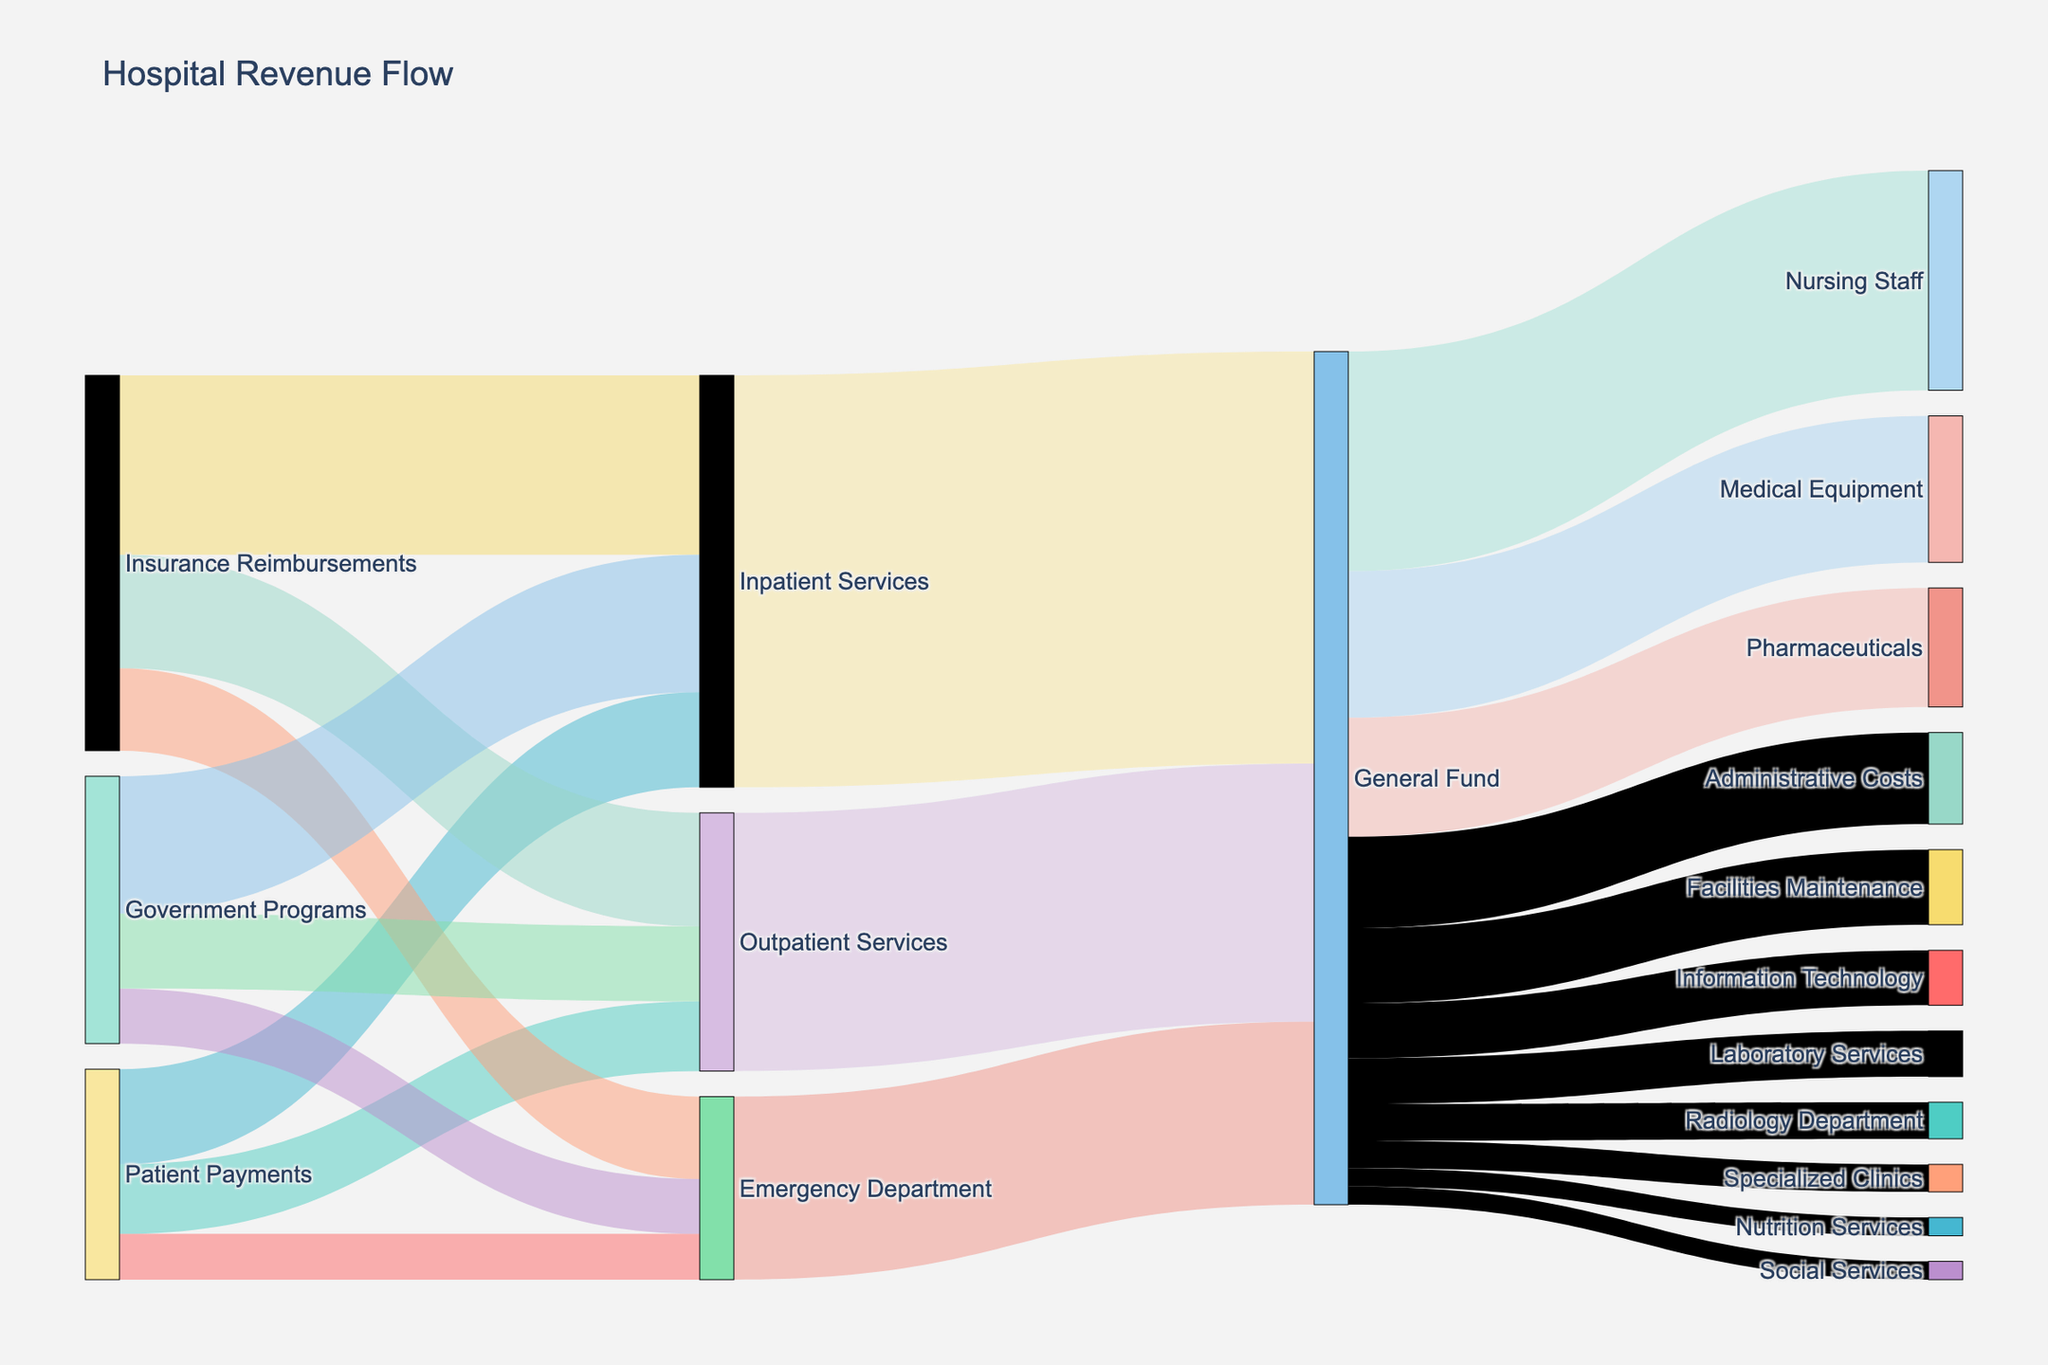What is the title of the diagram? The title of the diagram is prominently displayed at the top of the figure.
Answer: "Hospital Revenue Flow" What are the largest and smallest revenue contributions from Patient Payments? By looking at the width of the flows coming from "Patient Payments," we can see that their largest contribution is to "Inpatient Services" and the smallest is to the "Emergency Department".
Answer: Largest: "Inpatient Services", Smallest: "Emergency Department" Which department receives the highest total revenue from all sources combined? Summing the flows into each department (Emergency Department, Outpatient Services, Inpatient Services) from all sources (Patient Payments, Insurance Reimbursements, Government Programs), we see that "Inpatient Services" receives the most. Specifically, 5200000 from Patient Payments, 9800000 from Insurance Reimbursements, and 7500000 from Government Programs equal 22500000.
Answer: "Inpatient Services" How much revenue does the General Fund allocate to Medical Equipment and Nursing Staff? The flows from "General Fund" to "Medical Equipment" and "Nursing Staff" are visible, summing to 8000000 and 12000000 respectively.
Answer: $20,000,000 combined What is the combined value of revenues from Government Programs to the Emergency Department and Outpatient Services? Adding the values of the flows from "Government Programs" to "Emergency Department" and "Outpatient Services" gives 3000000 + 4100000.
Answer: $7,100,000 Compare the revenues from Insurance Reimbursements to Inpatient Services and Outpatient Services. Which is higher and by how much? By comparing the figures directly, Insurance Reimbursements to "Inpatient Services" is 9800000, and to "Outpatient Services" is 6200000. The difference is 9800000 - 6200000.
Answer: "Inpatient Services" by $3,600,000 What is the total revenue that flows into the General Fund from all departments? Adding the flows into "General Fund" from "Emergency Department" (10000000), "Outpatient Services" (14100000), and "Inpatient Services" (22500000) gives 10000000 + 14100000 + 22500000.
Answer: $46,000,000 Identify two services with equal funds allocated from the General Fund. Observing the flows from the "General Fund," "Social Services" and "Nutrition Services" each receive an equal allocation of 1000000.
Answer: "Social Services" and "Nutrition Services" Which flow is larger: from Government Programs to Emergency Department or from Patient Payments to Outpatient Services? By comparing the two specific flows, Government Programs to "Emergency Department" is 3000000, and Patient Payments to "Outpatient Services" is 3800000.
Answer: "Patient Payments to Outpatient Services" Determine the total revenue from Patient Payments and Insurance Reimbursements combined for Outpatient Services. Adding revenue from "Patient Payments" and "Insurance Reimbursements" to "Outpatient Services," 3800000 from Patient Payments and 6200000 from Insurance Reimbursements gives 3800000 + 6200000.
Answer: $10,000,000 